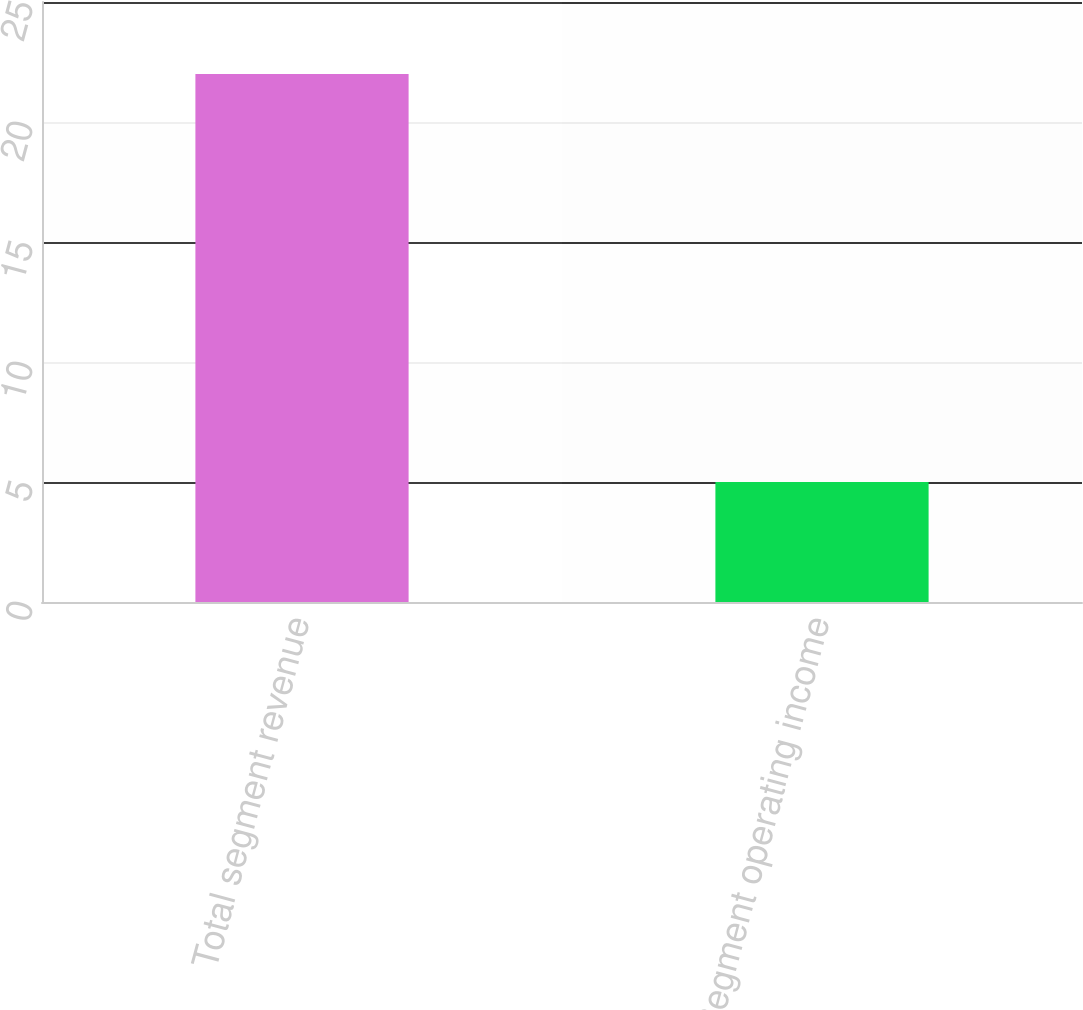<chart> <loc_0><loc_0><loc_500><loc_500><bar_chart><fcel>Total segment revenue<fcel>Segment operating income<nl><fcel>22<fcel>5<nl></chart> 